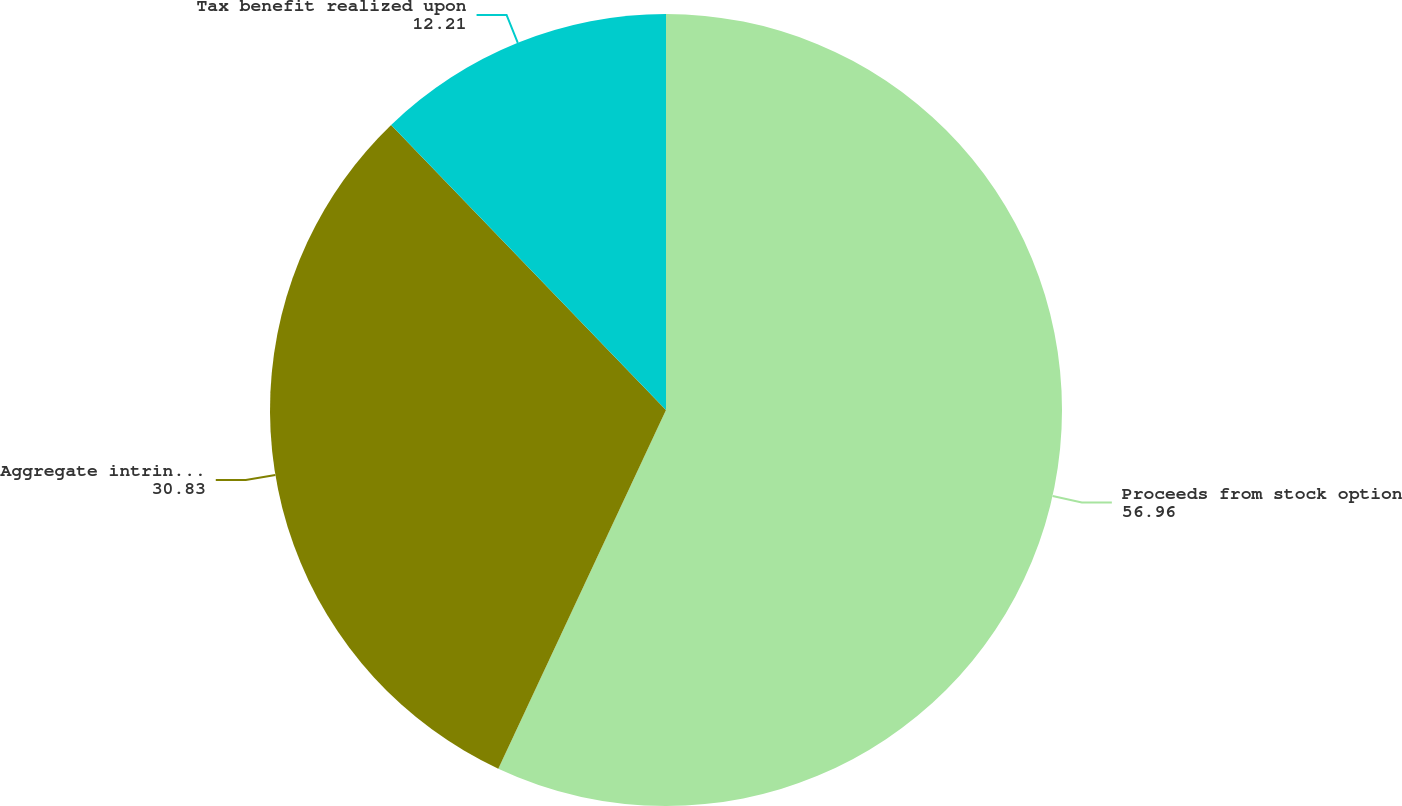<chart> <loc_0><loc_0><loc_500><loc_500><pie_chart><fcel>Proceeds from stock option<fcel>Aggregate intrinsic value<fcel>Tax benefit realized upon<nl><fcel>56.96%<fcel>30.83%<fcel>12.21%<nl></chart> 